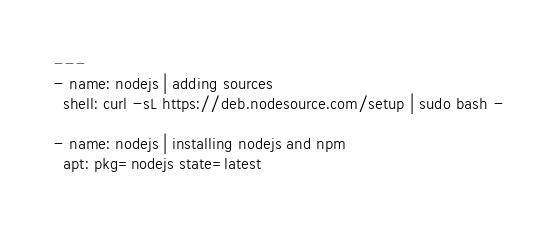Convert code to text. <code><loc_0><loc_0><loc_500><loc_500><_YAML_>---
- name: nodejs | adding sources
  shell: curl -sL https://deb.nodesource.com/setup | sudo bash -

- name: nodejs | installing nodejs and npm
  apt: pkg=nodejs state=latest</code> 